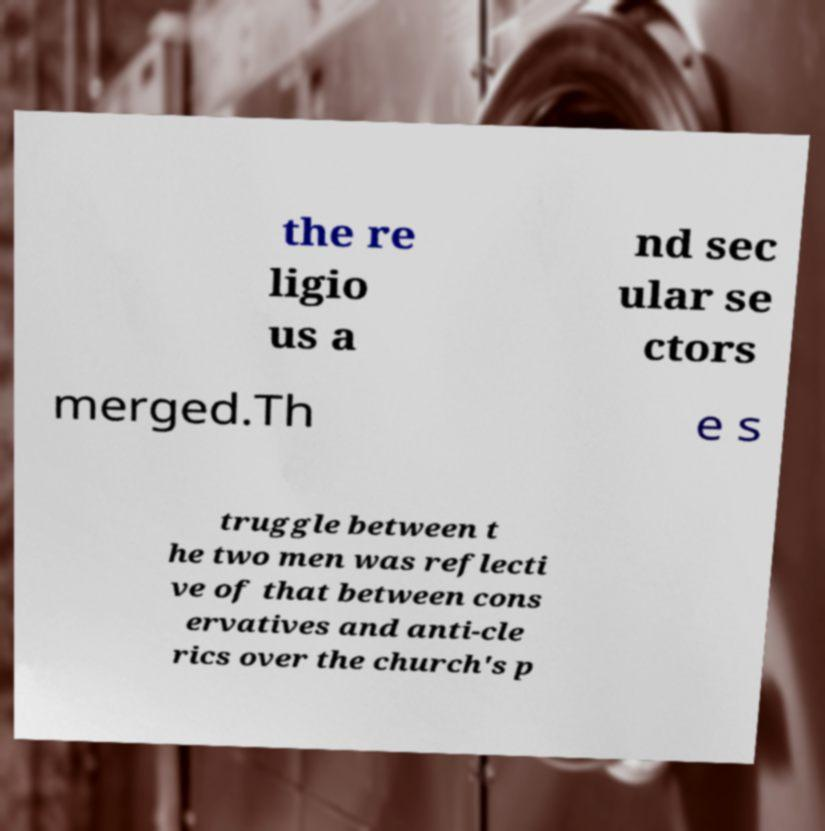Could you extract and type out the text from this image? the re ligio us a nd sec ular se ctors merged.Th e s truggle between t he two men was reflecti ve of that between cons ervatives and anti-cle rics over the church's p 